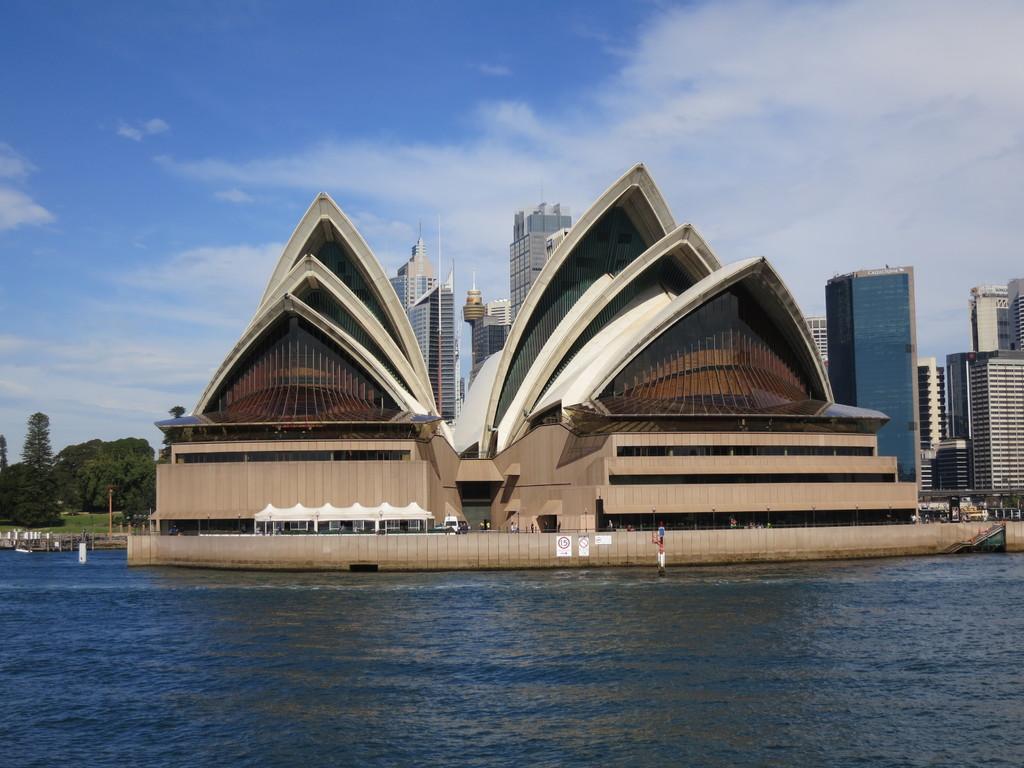Could you give a brief overview of what you see in this image? In this image we can see a building which is known as Sydney Opera House and we can see the water and there are some buildings in the background. We can see some trees on the left side of the image and at the top we can see the sky. 